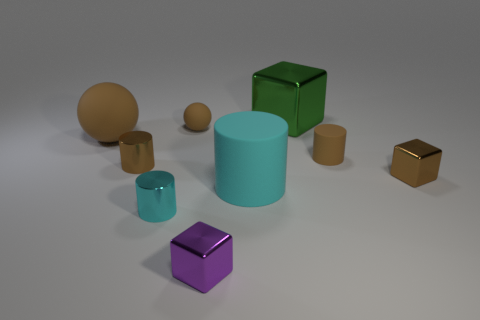Subtract 1 cylinders. How many cylinders are left? 3 Add 1 small brown shiny cylinders. How many objects exist? 10 Subtract all cylinders. How many objects are left? 5 Add 8 cyan rubber blocks. How many cyan rubber blocks exist? 8 Subtract 1 purple cubes. How many objects are left? 8 Subtract all large brown spheres. Subtract all large blue balls. How many objects are left? 8 Add 1 large matte balls. How many large matte balls are left? 2 